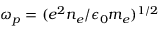Convert formula to latex. <formula><loc_0><loc_0><loc_500><loc_500>\omega _ { p } = ( e ^ { 2 } n _ { e } / \epsilon _ { 0 } m _ { e } ) ^ { 1 / 2 }</formula> 